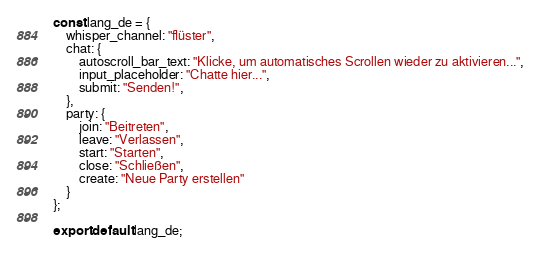Convert code to text. <code><loc_0><loc_0><loc_500><loc_500><_JavaScript_>
const lang_de = {
    whisper_channel: "flüster",
    chat: {
        autoscroll_bar_text: "Klicke, um automatisches Scrollen wieder zu aktivieren...",
        input_placeholder: "Chatte hier...",
        submit: "Senden!",
    },
    party: {
        join: "Beitreten",
        leave: "Verlassen",
        start: "Starten",
        close: "Schließen",
        create: "Neue Party erstellen"
    }
};

export default lang_de;
</code> 